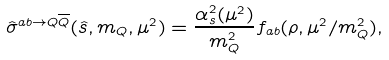Convert formula to latex. <formula><loc_0><loc_0><loc_500><loc_500>\hat { \sigma } ^ { a b \rightarrow Q \overline { Q } } ( \hat { s } , m _ { Q } , \mu ^ { 2 } ) = \frac { \alpha ^ { 2 } _ { s } ( \mu ^ { 2 } ) } { m ^ { 2 } _ { Q } } f _ { a b } ( \rho , \mu ^ { 2 } / m ^ { 2 } _ { Q } ) ,</formula> 